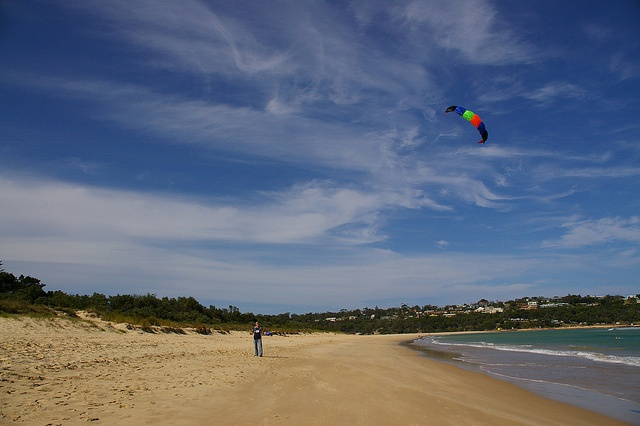Describe the objects in this image and their specific colors. I can see kite in navy, black, red, and darkblue tones and people in navy, black, gray, and tan tones in this image. 